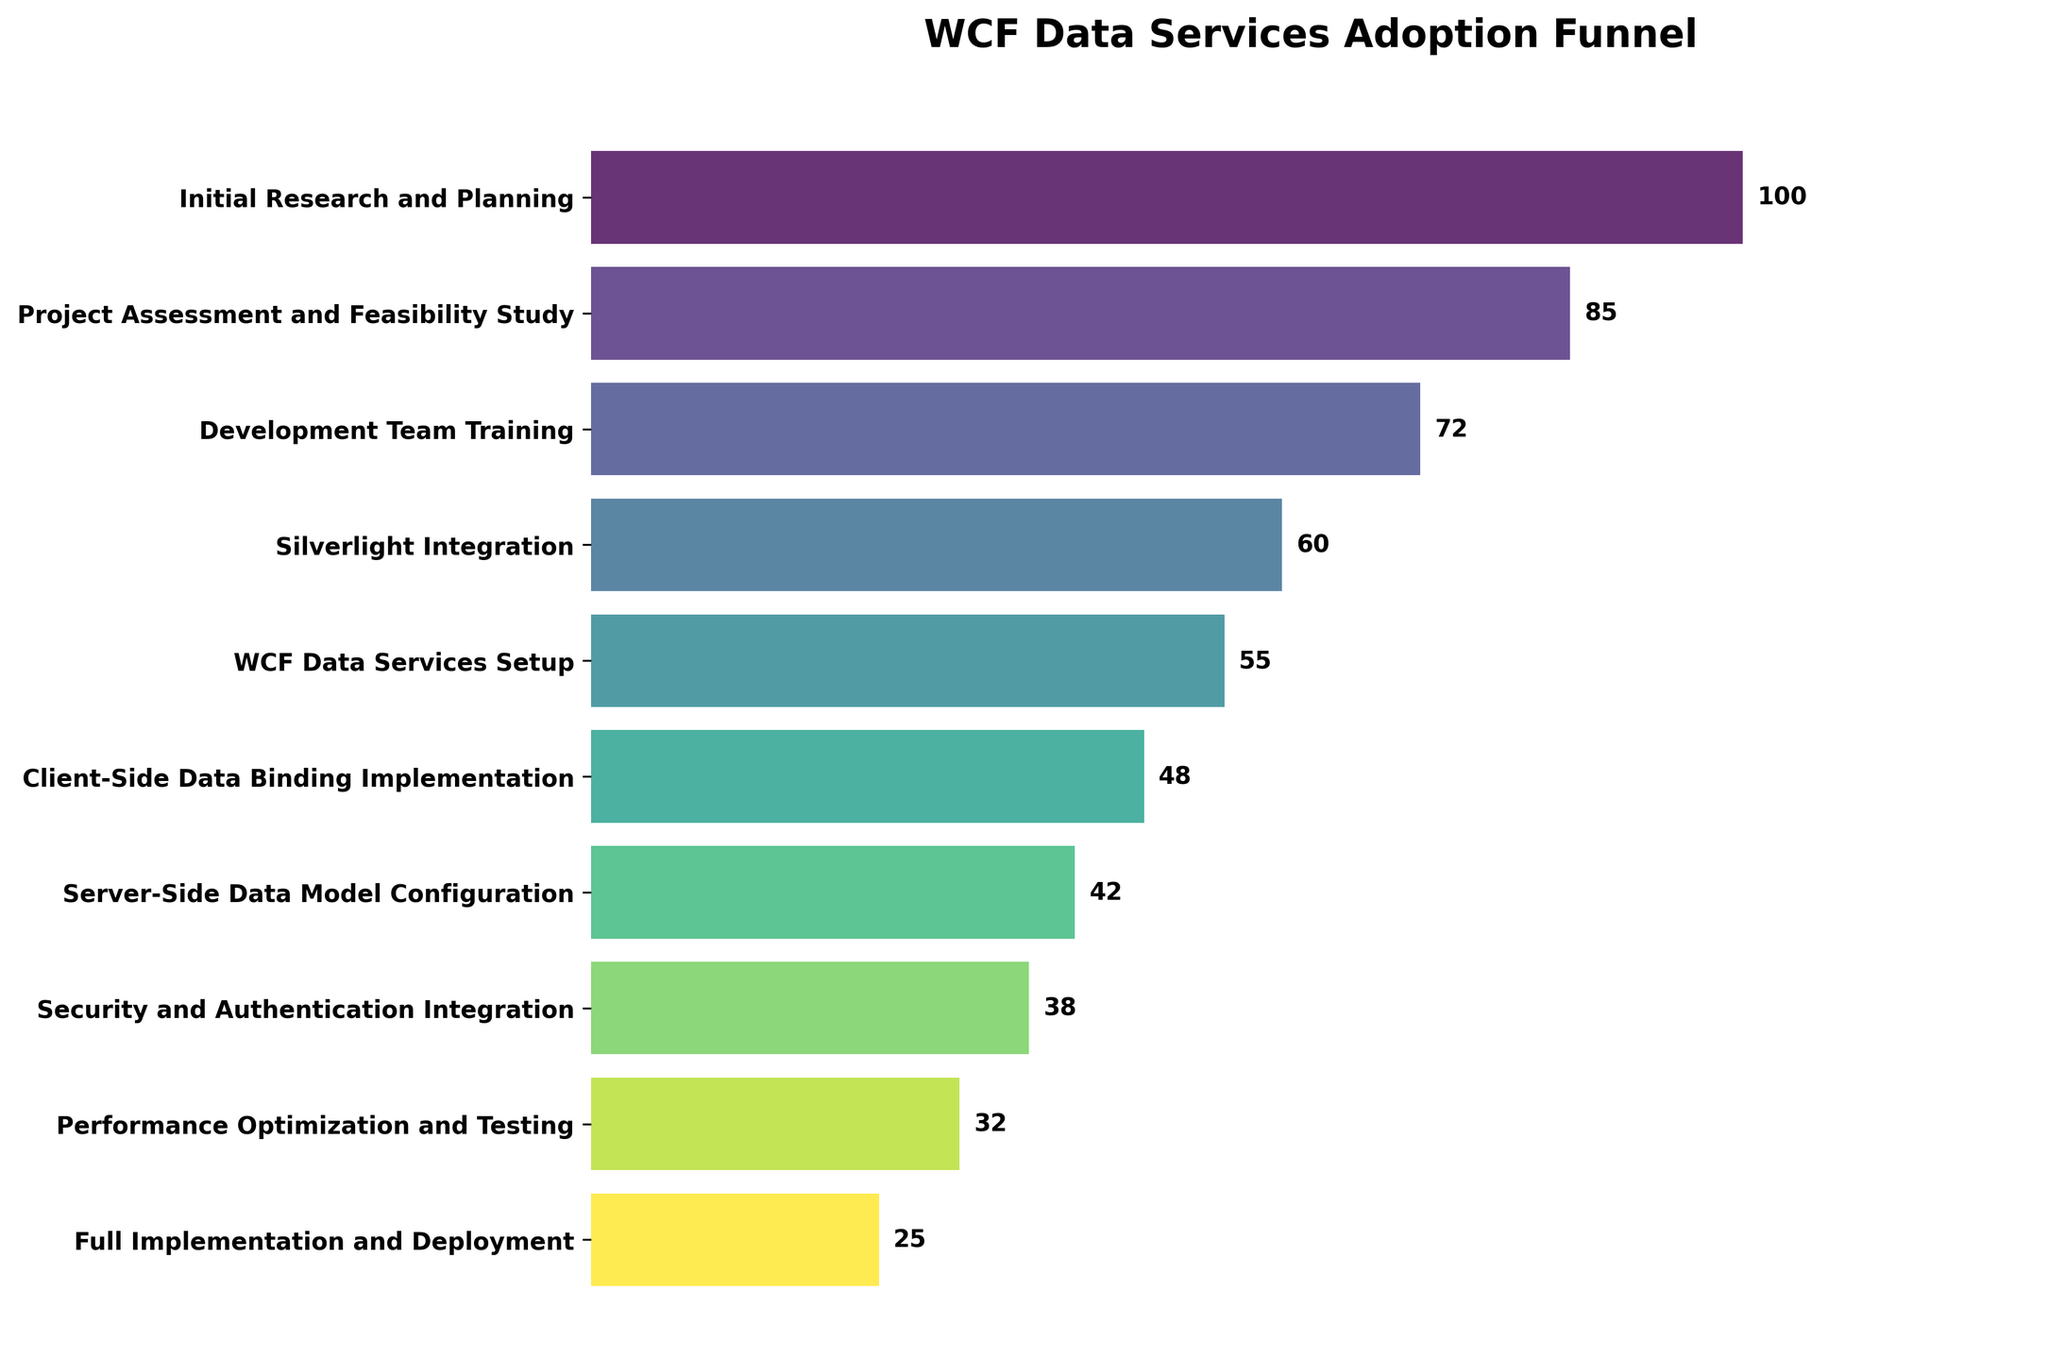what is the title of the figure? The title of the funnel chart is displayed prominently at the top center of the figure. It denotes the main topic or purpose of the chart.
Answer: "WCF Data Services Adoption Funnel" How many stages are there in the WCF Data Services adoption process? By counting the unique stages listed on the y-axis of the funnel chart, we can determine how many distinct steps are shown in the process.
Answer: 10 At which stage does the adoption process see the greatest drop-off in the number of projects? To determine this, we compare the number of projects from one stage to the next and identify where the greatest difference occurs. The largest drop is between "Initial Research and Planning" (100) and "Project Assessment and Feasibility Study" (85), a drop of 15.
Answer: "Initial Research and Planning" to "Project Assessment and Feasibility Study" How many projects are there at the final stage, "Full Implementation and Deployment"? The number of projects at the final stage is labeled directly next to the corresponding bar in the funnel chart.
Answer: 25 What is the combined number of projects at the "Development Team Training" and "Silverlight Integration" stages? Sum the number of projects at "Development Team Training" (72) and "Silverlight Integration" (60).
Answer: 132 Which stage has fewer projects: "Server-Side Data Model Configuration" or "Security and Authentication Integration"? By comparing the numbers next to the labels for these two stages, we can see that "Server-Side Data Model Configuration" has 42 projects while "Security and Authentication Integration" has 38 projects.
Answer: "Security and Authentication Integration" What is the percentage decrease in projects from "Silverlight Integration" to "Client-Side Data Binding Implementation"? First, find the number of projects at both stages: "Silverlight Integration" (60) and "Client-Side Data Binding Implementation" (48). The decrease in projects is 60 - 48 = 12. The percentage decrease is (12 / 60) * 100.
Answer: 20% Which stage immediately follows "WCF Data Services Setup"? To find this, locate "WCF Data Services Setup" on the y-axis and identify the stage that comes directly after it.
Answer: "Client-Side Data Binding Implementation" What stage has the smallest number of projects and what is its count? By identifying the shortest bar in the funnel chart and looking at the numerical label next to it, we find the stage with the smallest count.
Answer: "Full Implementation and Deployment" with 25 projects 